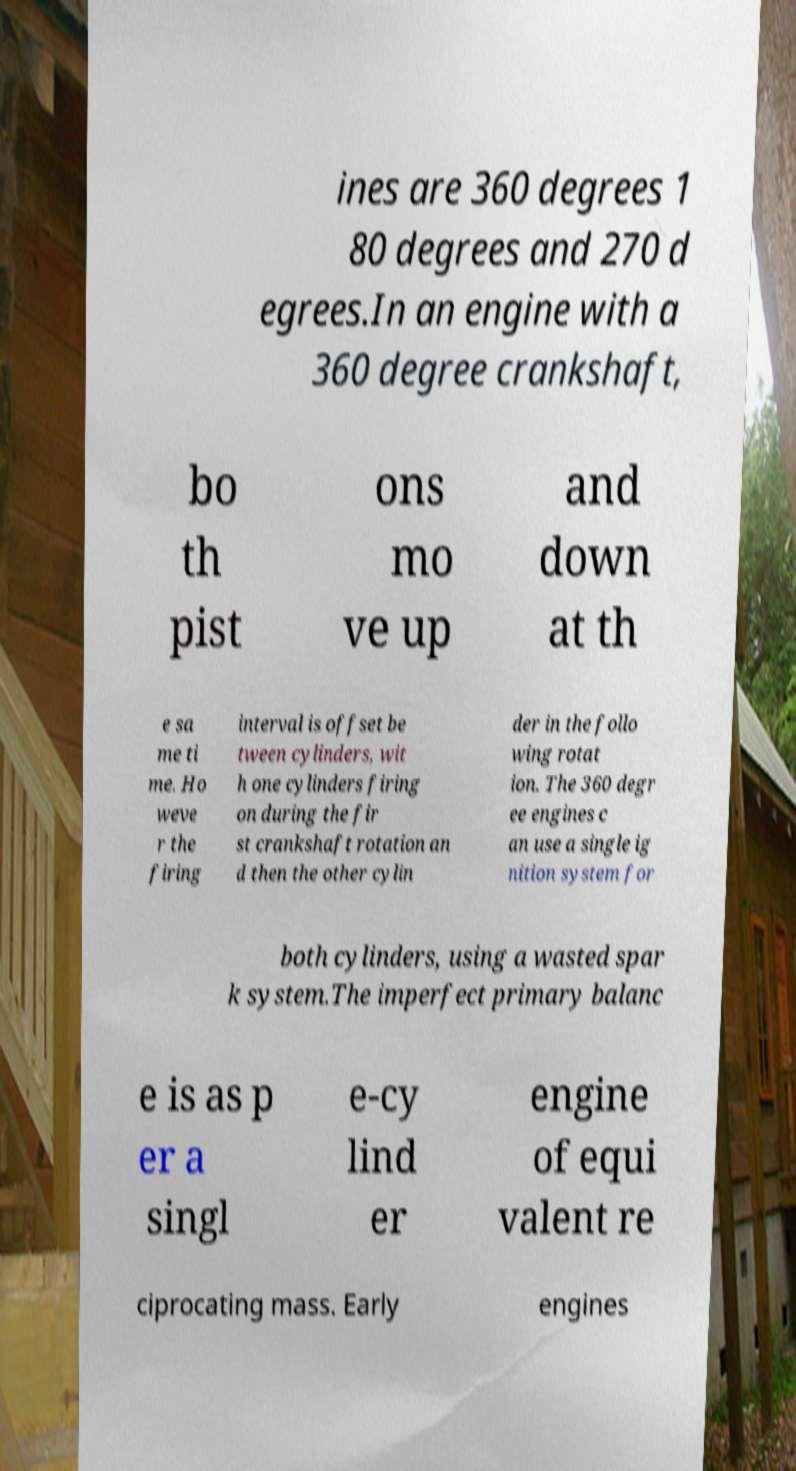Could you assist in decoding the text presented in this image and type it out clearly? ines are 360 degrees 1 80 degrees and 270 d egrees.In an engine with a 360 degree crankshaft, bo th pist ons mo ve up and down at th e sa me ti me. Ho weve r the firing interval is offset be tween cylinders, wit h one cylinders firing on during the fir st crankshaft rotation an d then the other cylin der in the follo wing rotat ion. The 360 degr ee engines c an use a single ig nition system for both cylinders, using a wasted spar k system.The imperfect primary balanc e is as p er a singl e-cy lind er engine of equi valent re ciprocating mass. Early engines 